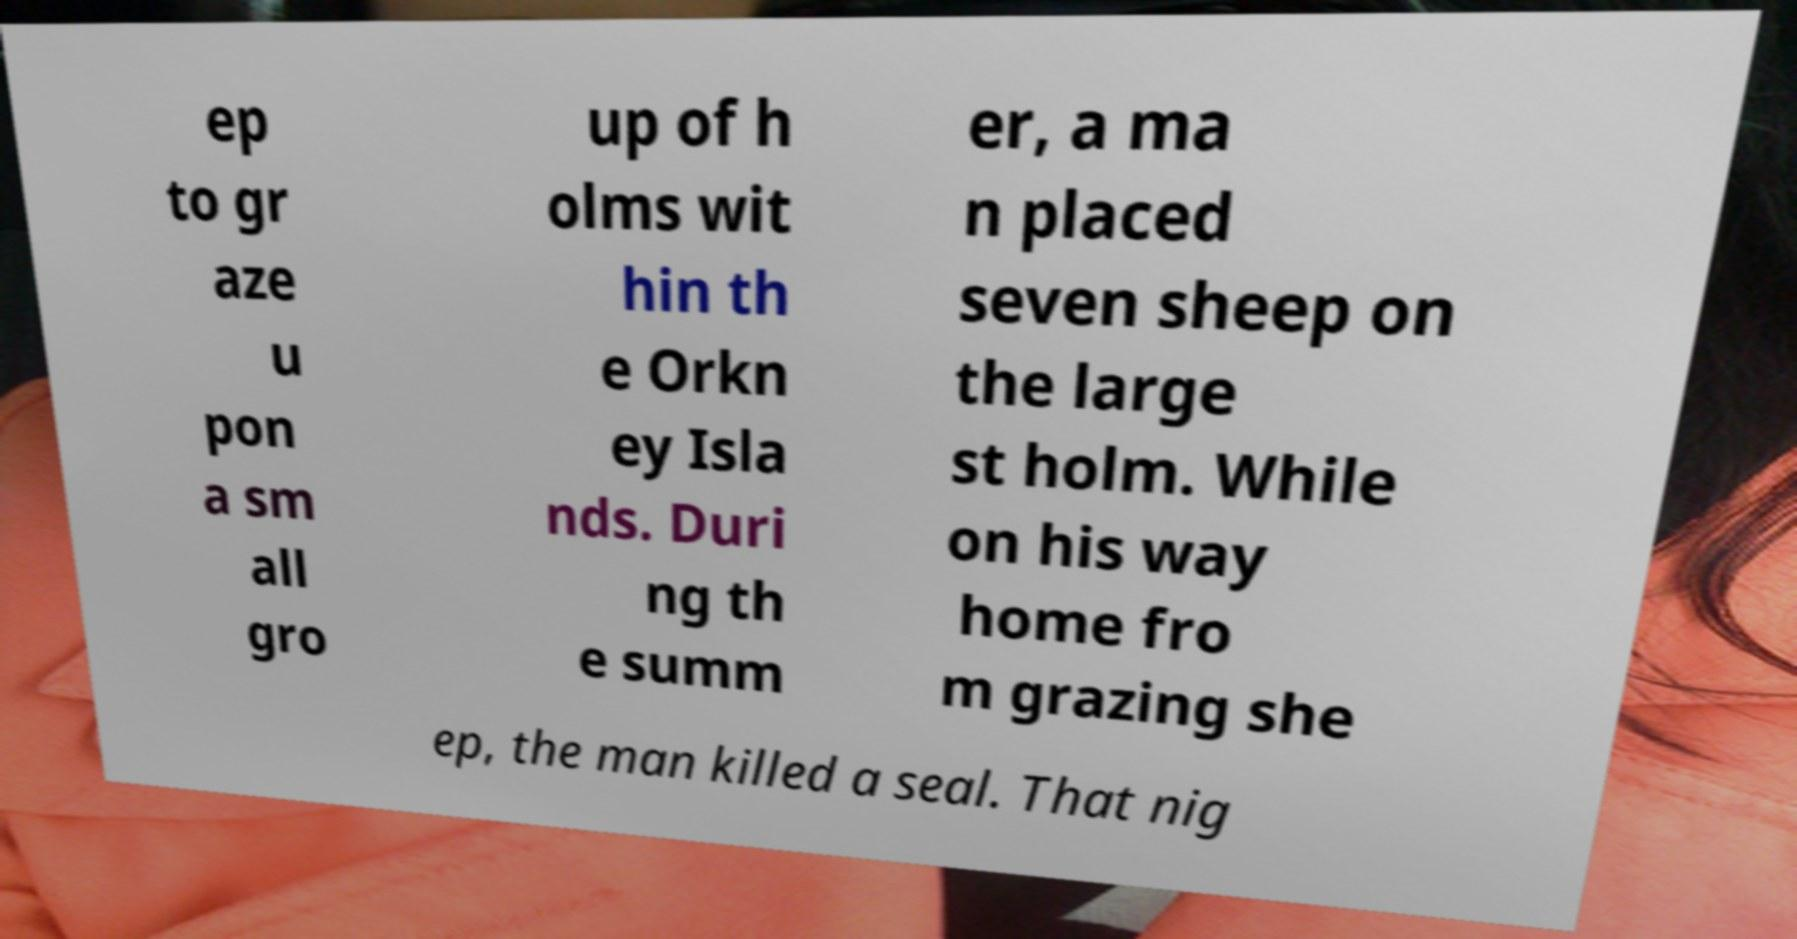There's text embedded in this image that I need extracted. Can you transcribe it verbatim? ep to gr aze u pon a sm all gro up of h olms wit hin th e Orkn ey Isla nds. Duri ng th e summ er, a ma n placed seven sheep on the large st holm. While on his way home fro m grazing she ep, the man killed a seal. That nig 